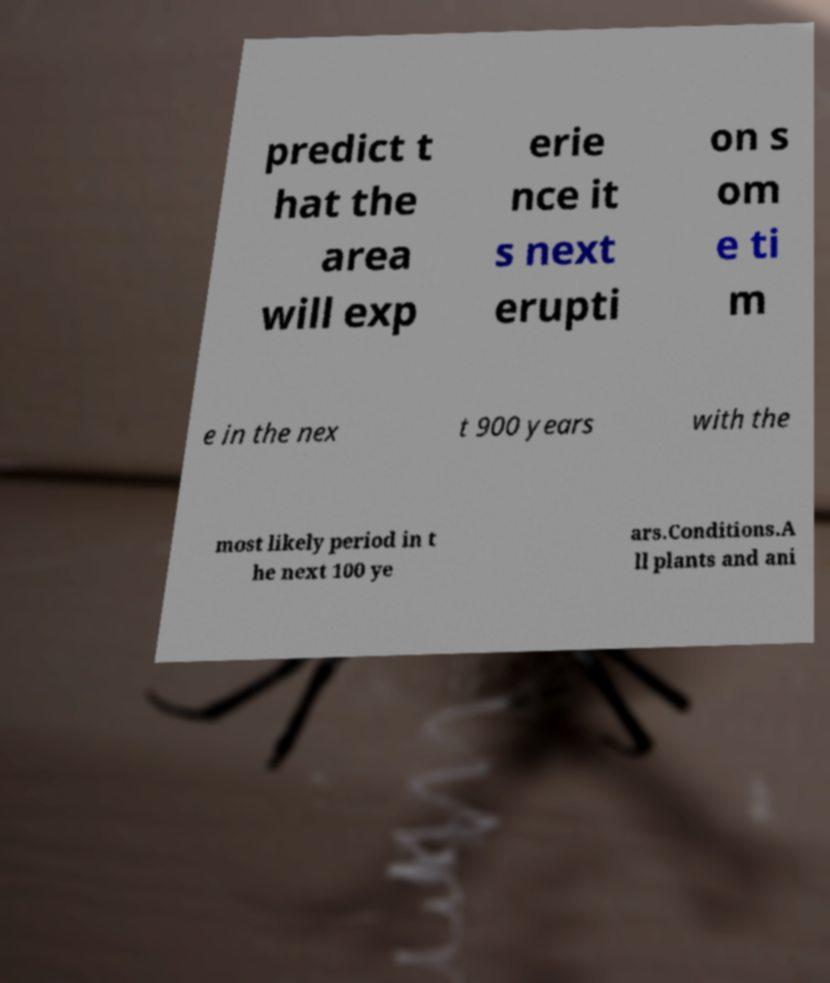What messages or text are displayed in this image? I need them in a readable, typed format. predict t hat the area will exp erie nce it s next erupti on s om e ti m e in the nex t 900 years with the most likely period in t he next 100 ye ars.Conditions.A ll plants and ani 